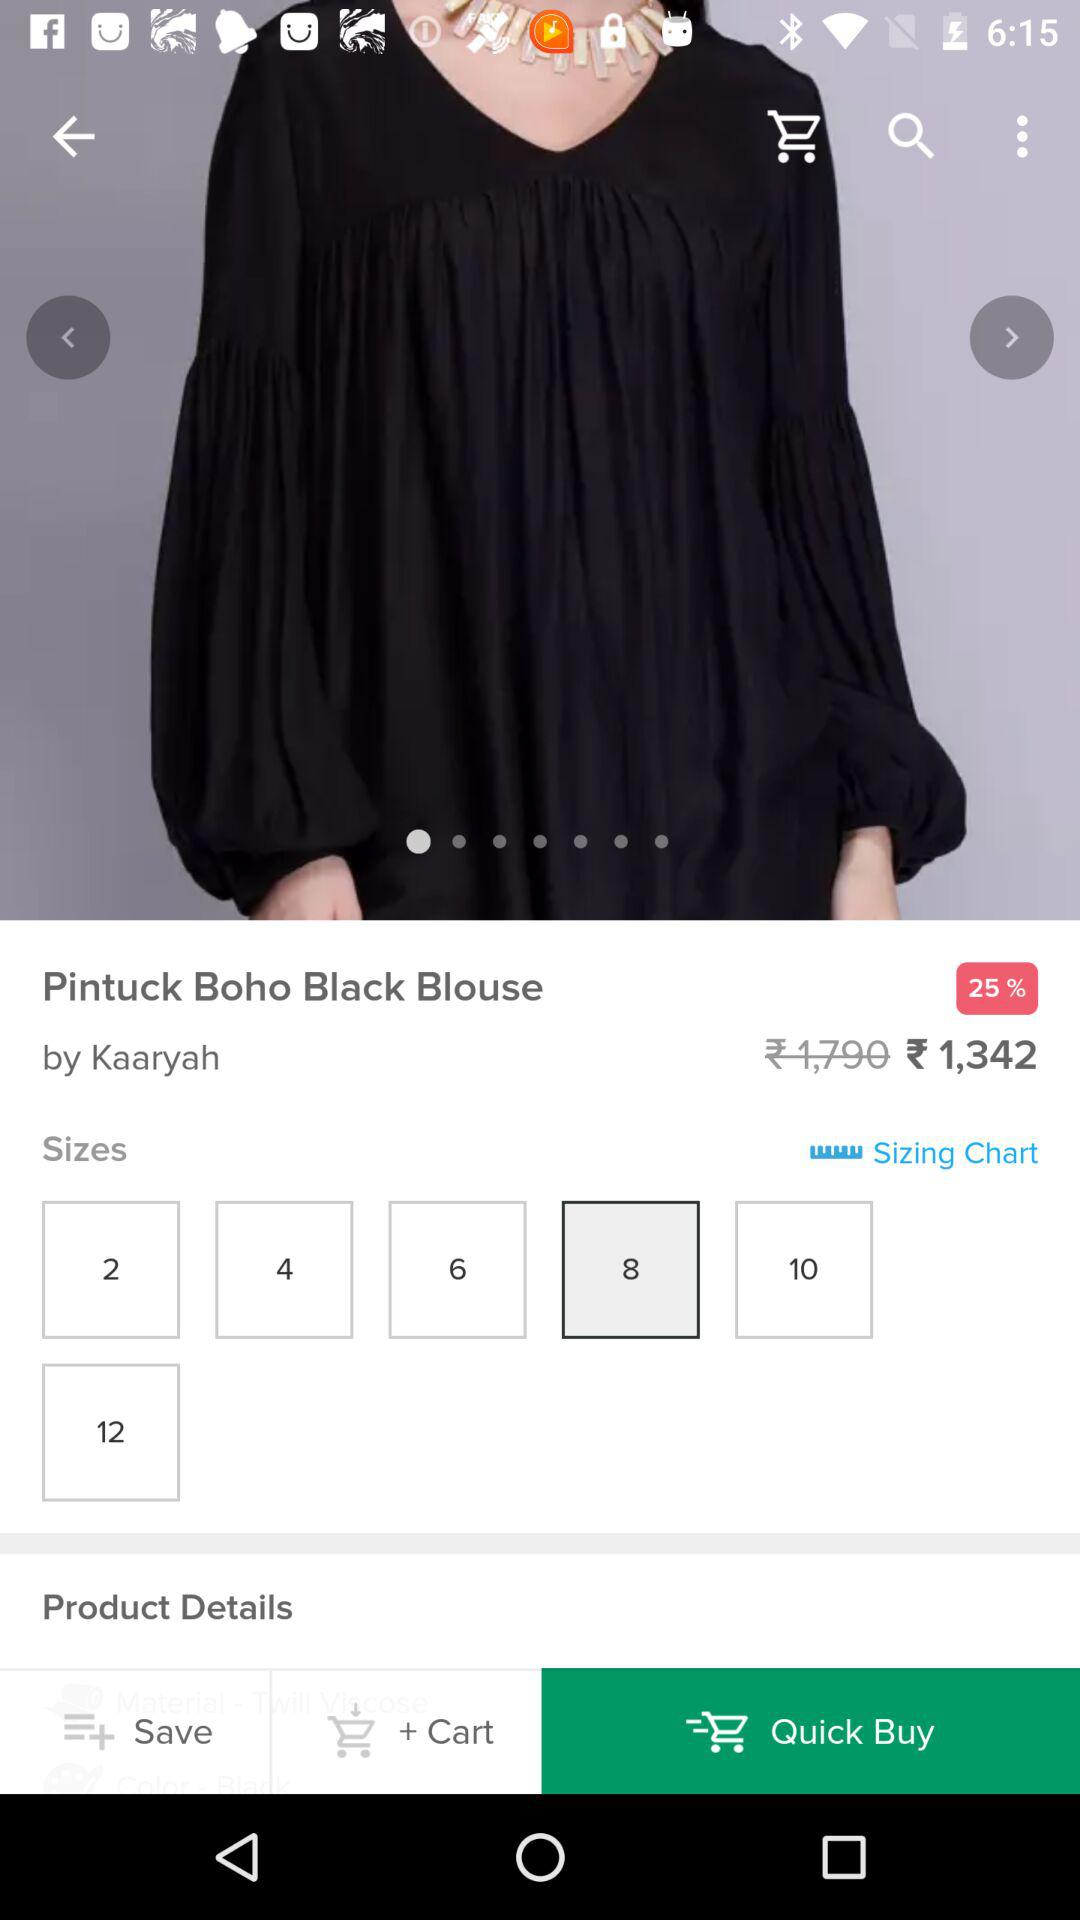What is the selected size? The selected size is 8. 